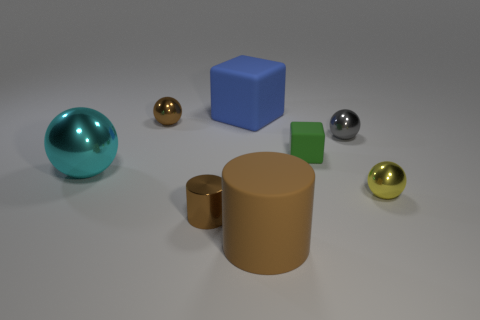Is there a yellow object that has the same material as the yellow ball?
Provide a short and direct response. No. Does the green cube have the same material as the tiny brown cylinder?
Provide a succinct answer. No. There is a rubber cube that is in front of the large blue cube; how many rubber objects are on the left side of it?
Make the answer very short. 2. How many purple things are either metallic spheres or small spheres?
Provide a short and direct response. 0. There is a tiny brown object that is behind the thing that is left of the tiny metal ball on the left side of the gray ball; what shape is it?
Offer a terse response. Sphere. The cube that is the same size as the yellow ball is what color?
Offer a terse response. Green. How many big blue rubber things are the same shape as the brown rubber thing?
Your answer should be very brief. 0. Do the shiny cylinder and the blue matte block to the left of the big brown rubber cylinder have the same size?
Provide a succinct answer. No. What is the shape of the small brown shiny thing that is behind the brown metallic thing that is in front of the large cyan metallic thing?
Provide a short and direct response. Sphere. Are there fewer small brown cylinders that are left of the brown sphere than purple metal cylinders?
Ensure brevity in your answer.  No. 